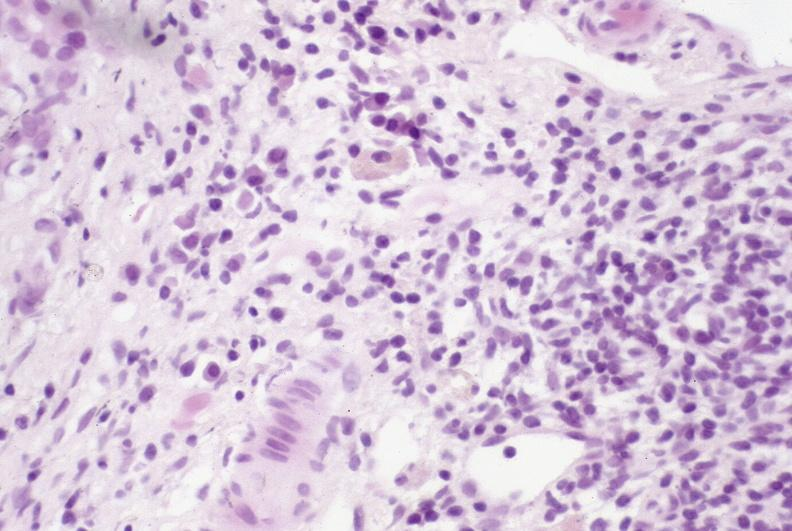what is present?
Answer the question using a single word or phrase. Liver 